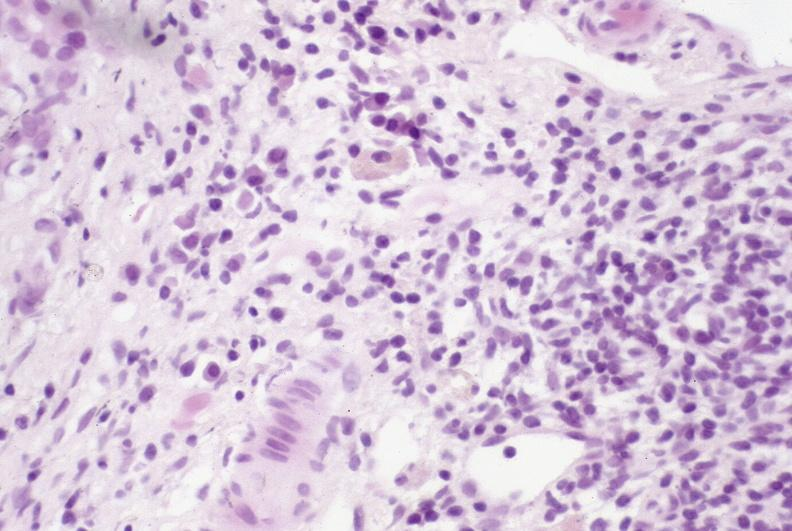what is present?
Answer the question using a single word or phrase. Liver 